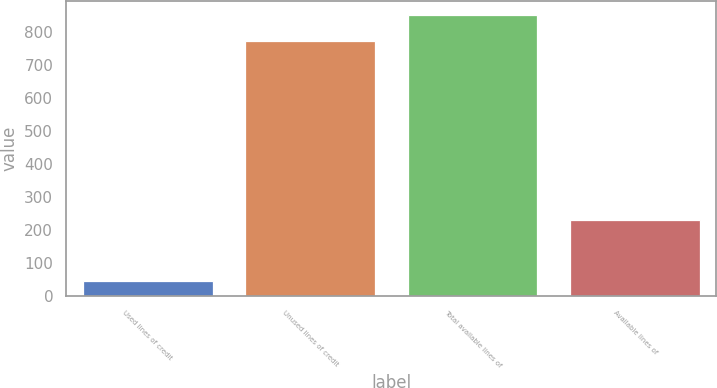<chart> <loc_0><loc_0><loc_500><loc_500><bar_chart><fcel>Used lines of credit<fcel>Unused lines of credit<fcel>Total available lines of<fcel>Available lines of<nl><fcel>46.7<fcel>773.4<fcel>850.74<fcel>231.3<nl></chart> 